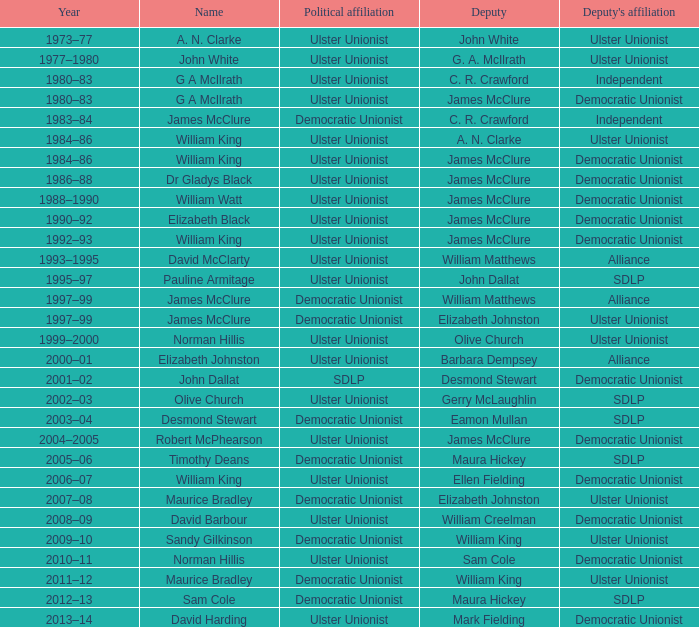During which year was james mcclure a deputy, and is the name of the person robert mcphearson? 2004–2005. 